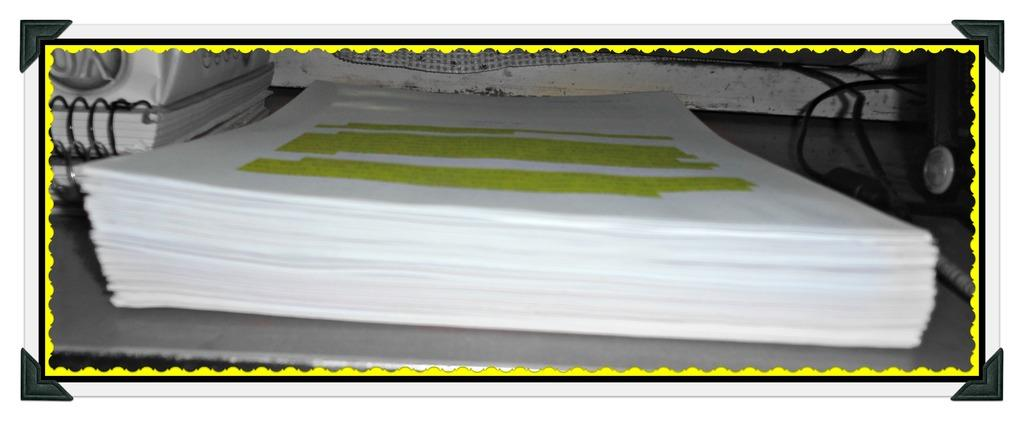What type of items are bundled together in the image? There is a bundle of papers in the image. What other items can be seen in the image besides the bundle of papers? There are books and cables in the image. On what object are the papers, books, and cables placed? The objects are on another object. What type of scarf is draped over the bundle of papers in the image? There is no scarf present in the image. What type of thread is used to bind the books together in the image? The image does not show any thread used to bind the books together. 